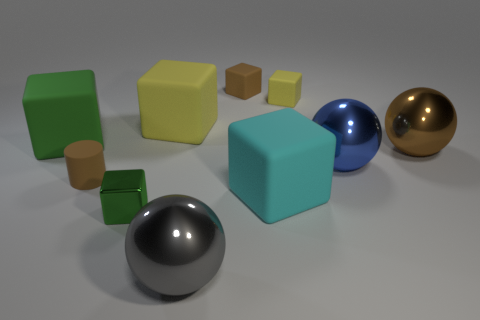Subtract all brown blocks. How many blocks are left? 5 Subtract all big cyan cubes. How many cubes are left? 5 Subtract all cyan cubes. Subtract all green cylinders. How many cubes are left? 5 Subtract all spheres. How many objects are left? 7 Add 8 green rubber objects. How many green rubber objects exist? 9 Subtract 0 yellow cylinders. How many objects are left? 10 Subtract all green shiny objects. Subtract all large cyan cubes. How many objects are left? 8 Add 6 brown matte cubes. How many brown matte cubes are left? 7 